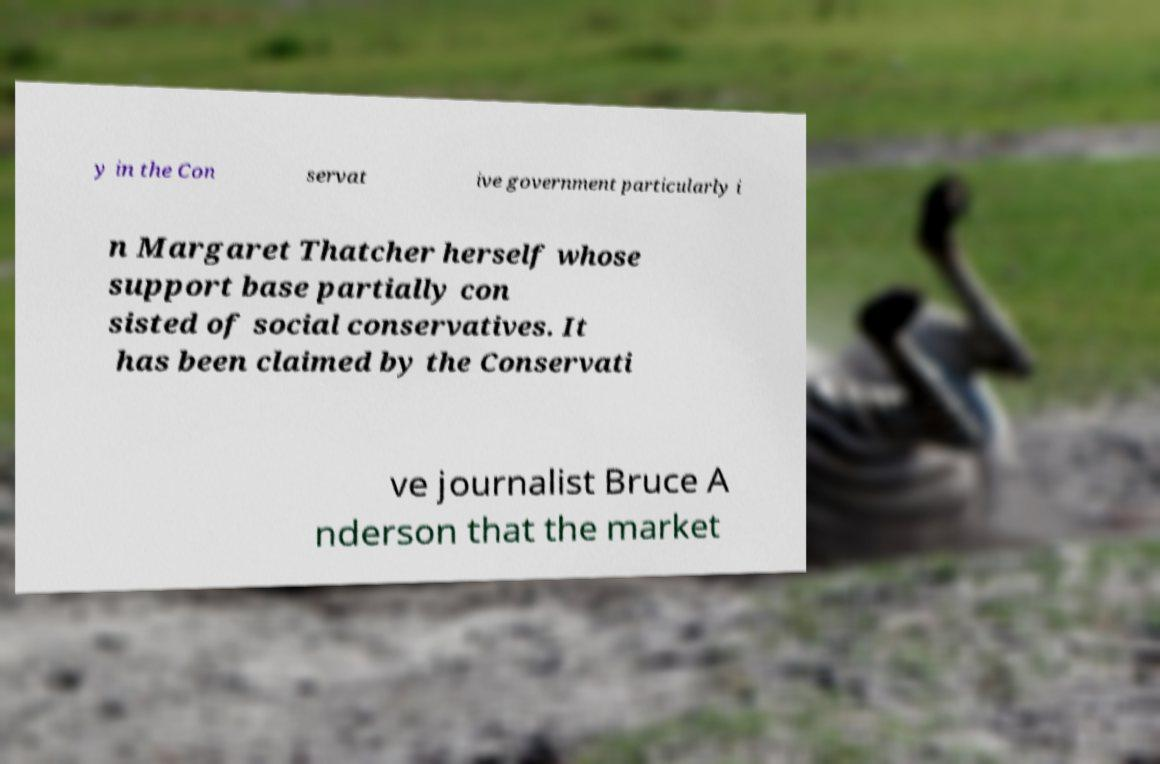What messages or text are displayed in this image? I need them in a readable, typed format. y in the Con servat ive government particularly i n Margaret Thatcher herself whose support base partially con sisted of social conservatives. It has been claimed by the Conservati ve journalist Bruce A nderson that the market 